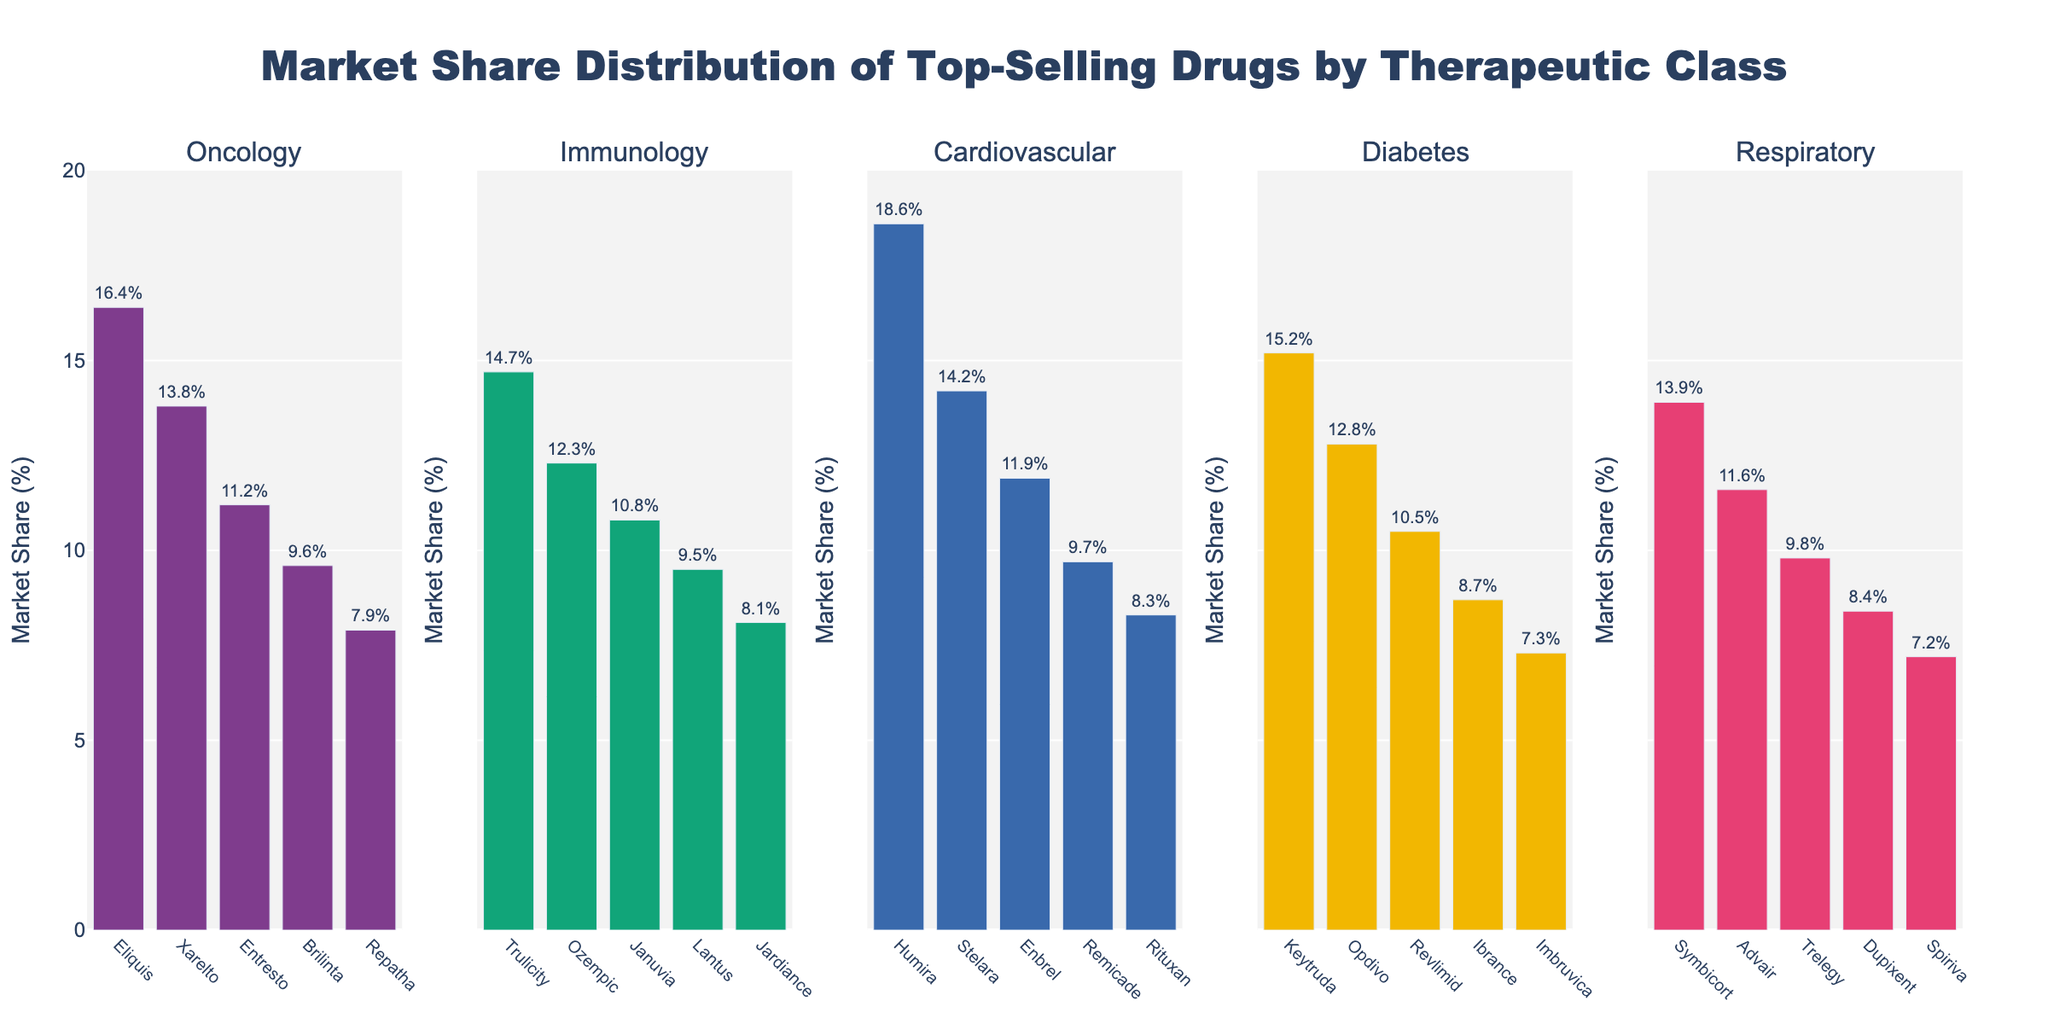What is the market share of "Keytruda" in the Oncology class? The bar corresponding to "Keytruda" in the Oncology class shows it has a market share of 15.2%.
Answer: 15.2% How does the market share of "Humira" compare to that of "Enbrel" in the Immunology class? "Humira" has a market share of 18.6%, while "Enbrel" has a market share of 11.9%. Therefore, "Humira" has a higher market share than "Enbrel".
Answer: Humira has a higher market share than Enbrel Which drug has the lowest market share in the Respiratory class? By observing the bars in the Respiratory class, "Spiriva" has the shortest bar, indicating the lowest market share of 7.2%.
Answer: Spiriva What is the total market share of all the drugs in the Cardiovascular class? The sum of the market shares for drugs in the Cardiovascular class is 16.4 + 13.8 + 11.2 + 9.6 + 7.9. Therefore, the total market share is 58.9%.
Answer: 58.9% In the Diabetes class, which drug has a market share closest to 10%? "Januvia" in the Diabetes class has a market share of 10.8%, which is closest to 10%.
Answer: Januvia Which therapeutic class has the highest average market share for its top-selling drugs? To determine the average market share for each class: Oncology (15.2 + 12.8 + 10.5 + 8.7 + 7.3 = 54.5 / 5 = 10.9), Immunology (18.6 + 14.2 + 11.9 + 9.7 + 8.3 = 62.7 / 5 = 12.54), Cardiovascular (16.4 + 13.8 + 11.2 + 9.6 + 7.9 = 58.9 / 5 = 11.78), Diabetes (14.7 + 12.3 + 10.8 + 9.5 + 8.1 = 55.4 / 5 = 11.08), Respiratory (13.9 + 11.6 + 9.8 + 8.4 + 7.2 = 50.9 / 5 = 10.18). Thus, the Immunology class has the highest average market share.
Answer: Immunology Is "Ozempic" in the Diabetes class outperforming "Stelara" in the Immunology class in terms of market share? "Ozempic" has a market share of 12.3%, whereas "Stelara" has a market share of 14.2%. Therefore, "Stelara" is outperforming "Ozempic" in terms of market share.
Answer: No What is the difference in market share between "Eliquis" and "Repatha" in the Cardiovascular class? "Eliquis" has a market share of 16.4% and "Repatha" has a market share of 7.9%. The difference is 16.4 - 7.9 = 8.5%.
Answer: 8.5% Which drug has a higher market share: "Revlimid" in Oncology or "Trelegy" in Respiratory? "Revlimid" has a market share of 10.5% and "Trelegy" has a market share of 9.8%. Therefore, "Revlimid" has a higher market share than "Trelegy".
Answer: Revlimid 